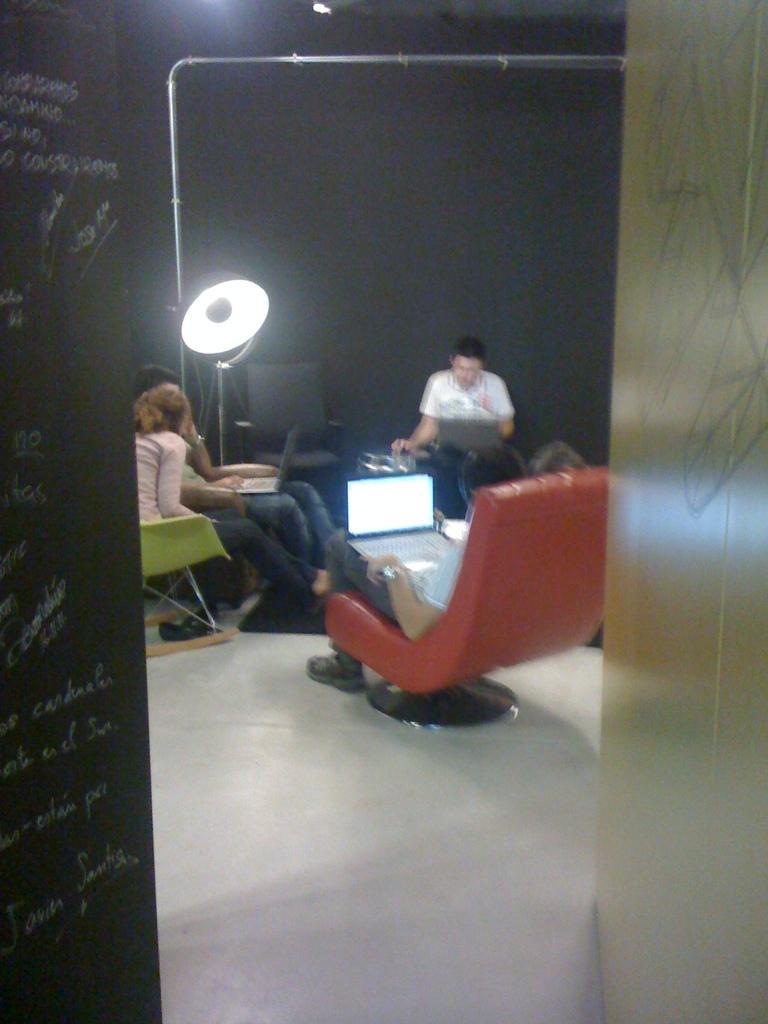How would you summarize this image in a sentence or two? In the image we can see there are people who are sitting on chair and there are laptops in their lap. 